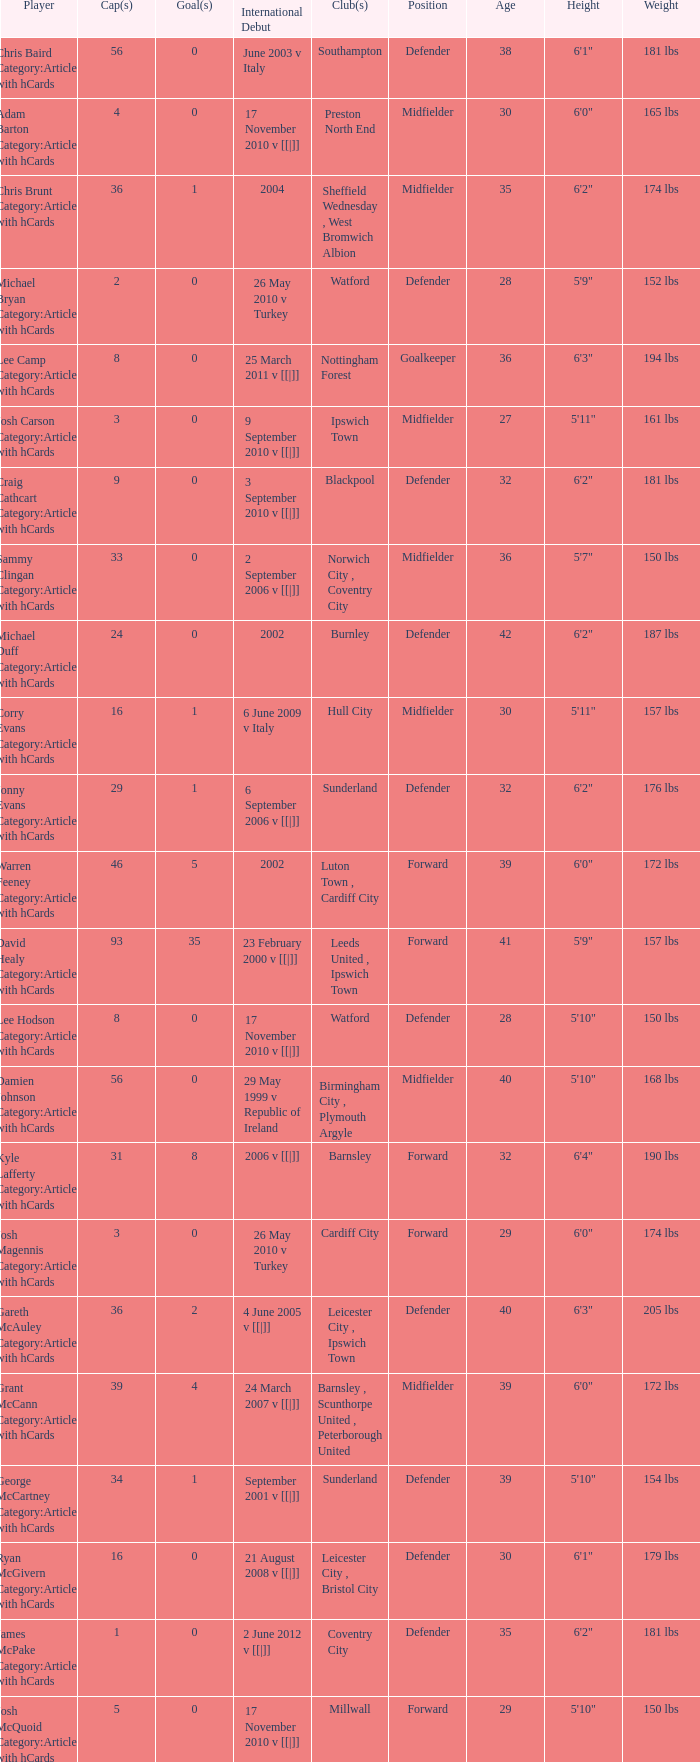How many caps figures are there for Norwich City, Coventry City? 1.0. 